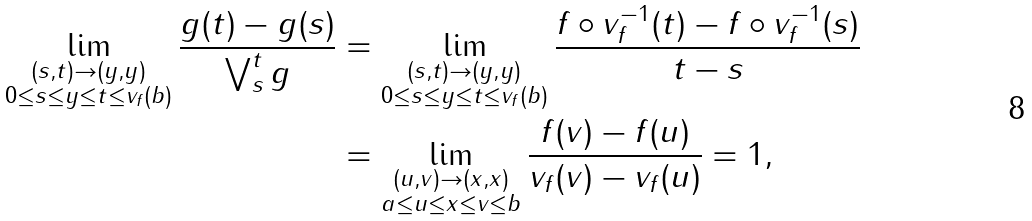<formula> <loc_0><loc_0><loc_500><loc_500>\lim _ { \substack { ( s , t ) \to ( y , y ) \\ 0 \leq s \leq y \leq t \leq v _ { f } ( b ) } } \frac { \| g ( t ) - g ( s ) \| } { \bigvee ^ { t } _ { s } g } & = \lim _ { \substack { ( s , t ) \to ( y , y ) \\ 0 \leq s \leq y \leq t \leq v _ { f } ( b ) } } \frac { \| f \circ v ^ { - 1 } _ { f } ( t ) - f \circ v ^ { - 1 } _ { f } ( s ) \| } { t - s } \\ & = \lim _ { \substack { ( u , v ) \to ( x , x ) \\ a \leq u \leq x \leq v \leq b } } \frac { \| f ( v ) - f ( u ) \| } { v _ { f } ( v ) - v _ { f } ( u ) } = 1 ,</formula> 